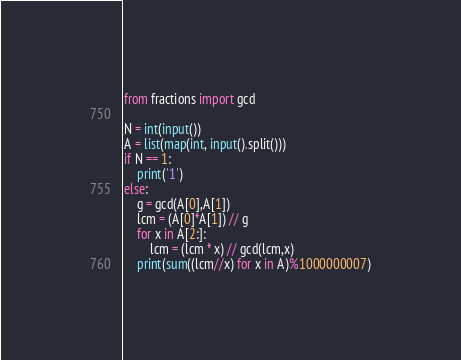<code> <loc_0><loc_0><loc_500><loc_500><_Python_>from fractions import gcd

N = int(input())
A = list(map(int, input().split()))
if N == 1:
    print('1')
else:
    g = gcd(A[0],A[1])
    lcm = (A[0]*A[1]) // g
    for x in A[2:]:
        lcm = (lcm * x) // gcd(lcm,x)
    print(sum((lcm//x) for x in A)%1000000007)</code> 